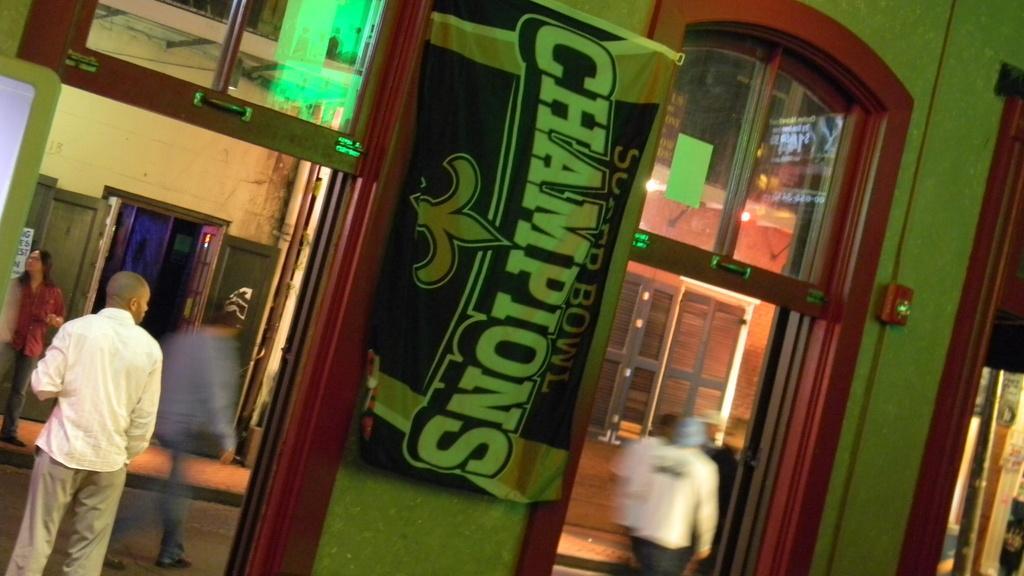Describe this image in one or two sentences. In this picture I can see some people walking, there is a man standing on the left and there are two doors here and here I can see there is a banner and there is a wall in the backdrop. 